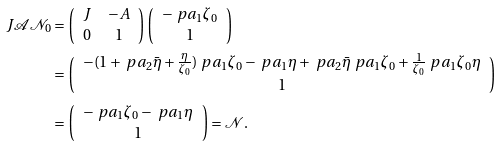Convert formula to latex. <formula><loc_0><loc_0><loc_500><loc_500>J \mathcal { A } \mathcal { N } _ { 0 } & = \left ( \begin{array} { c c } J & - A \\ 0 & 1 \end{array} \right ) \left ( \begin{array} { c } - \ p a _ { 1 } \zeta _ { 0 } \\ 1 \end{array} \right ) \\ & = \left ( \begin{array} { c } - ( 1 + \ p a _ { 2 } \bar { \eta } + \frac { \eta } { \zeta _ { 0 } } ) \ p a _ { 1 } \zeta _ { 0 } - \ p a _ { 1 } \eta + \ p a _ { 2 } \bar { \eta } \ p a _ { 1 } \zeta _ { 0 } + \frac { 1 } { \zeta _ { 0 } } \ p a _ { 1 } \zeta _ { 0 } \eta \\ 1 \end{array} \right ) \\ & = \left ( \begin{array} { c } - \ p a _ { 1 } \zeta _ { 0 } - \ p a _ { 1 } \eta \\ 1 \end{array} \right ) = \mathcal { N } .</formula> 